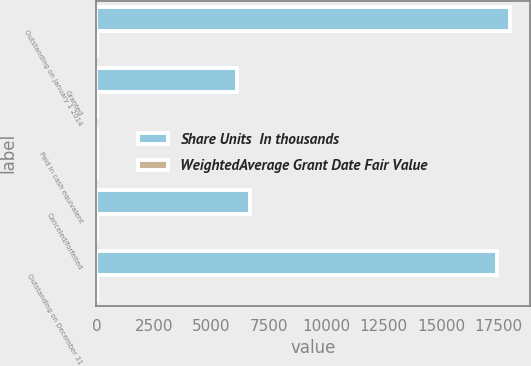<chart> <loc_0><loc_0><loc_500><loc_500><stacked_bar_chart><ecel><fcel>Outstanding on January 1 2014<fcel>Granted<fcel>Paid in cash equivalent<fcel>Canceled/forfeited<fcel>Outstanding on December 31<nl><fcel>Share Units  In thousands<fcel>17974<fcel>6117<fcel>5<fcel>6660<fcel>17426<nl><fcel>WeightedAverage Grant Date Fair Value<fcel>30.41<fcel>32.33<fcel>30.59<fcel>29.11<fcel>31.59<nl></chart> 